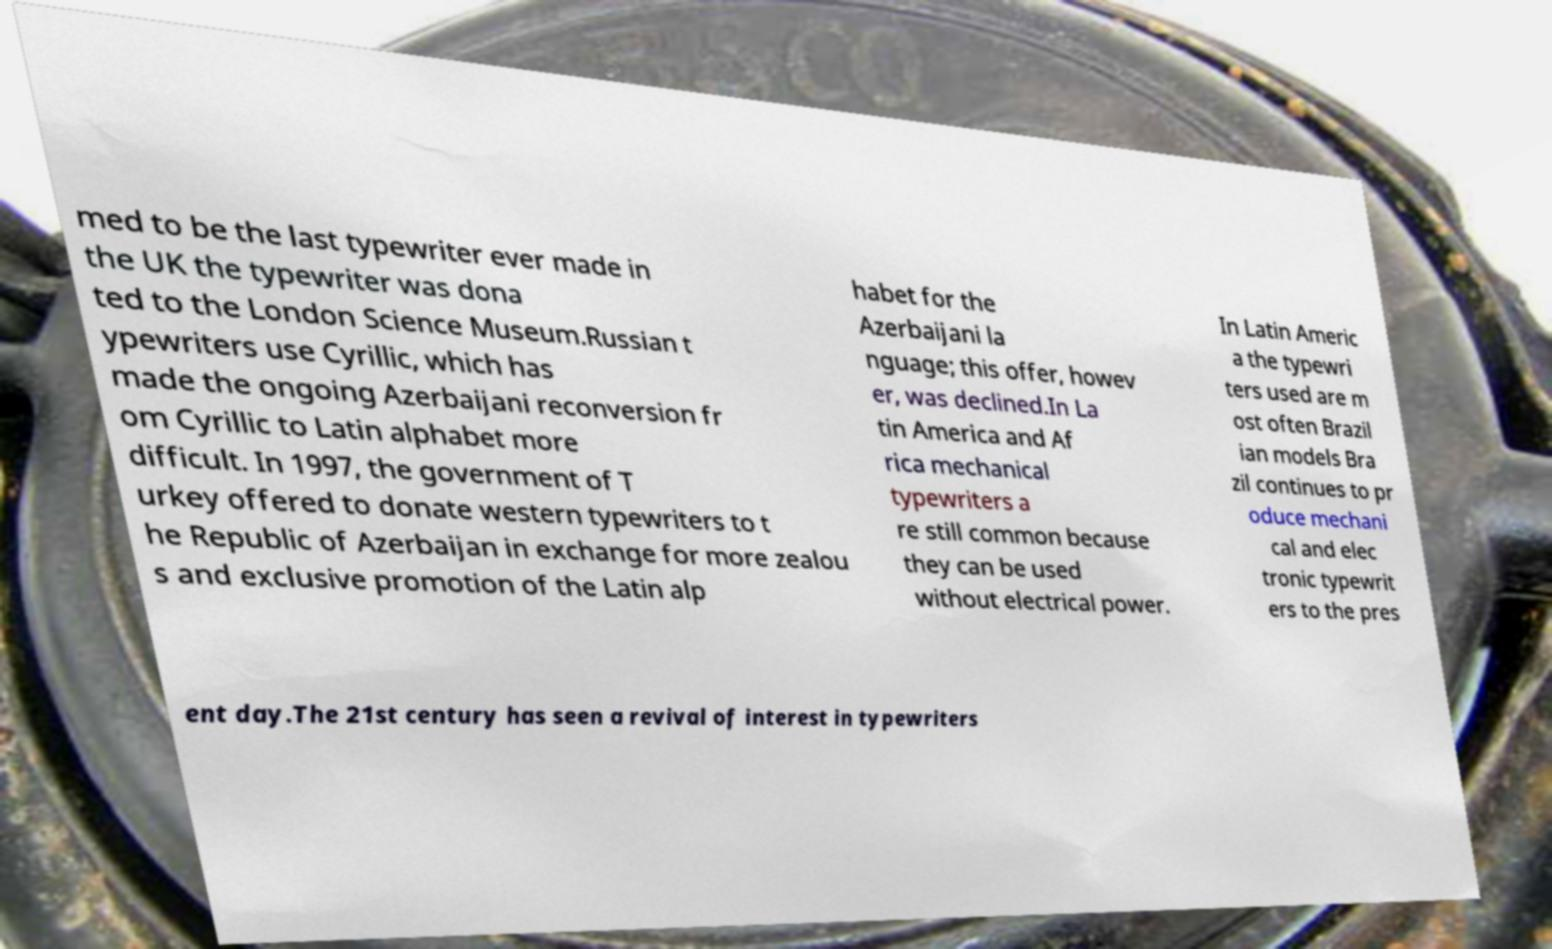For documentation purposes, I need the text within this image transcribed. Could you provide that? med to be the last typewriter ever made in the UK the typewriter was dona ted to the London Science Museum.Russian t ypewriters use Cyrillic, which has made the ongoing Azerbaijani reconversion fr om Cyrillic to Latin alphabet more difficult. In 1997, the government of T urkey offered to donate western typewriters to t he Republic of Azerbaijan in exchange for more zealou s and exclusive promotion of the Latin alp habet for the Azerbaijani la nguage; this offer, howev er, was declined.In La tin America and Af rica mechanical typewriters a re still common because they can be used without electrical power. In Latin Americ a the typewri ters used are m ost often Brazil ian models Bra zil continues to pr oduce mechani cal and elec tronic typewrit ers to the pres ent day.The 21st century has seen a revival of interest in typewriters 